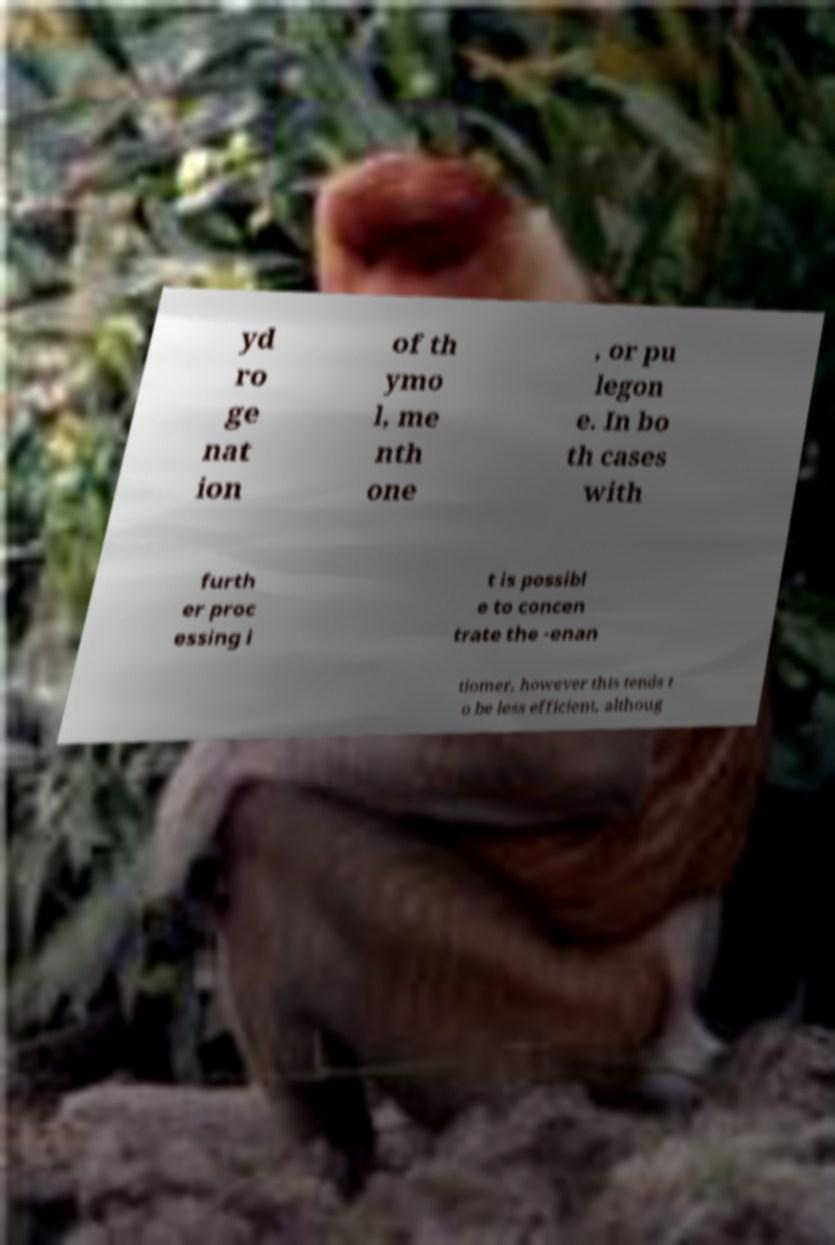What messages or text are displayed in this image? I need them in a readable, typed format. yd ro ge nat ion of th ymo l, me nth one , or pu legon e. In bo th cases with furth er proc essing i t is possibl e to concen trate the -enan tiomer, however this tends t o be less efficient, althoug 